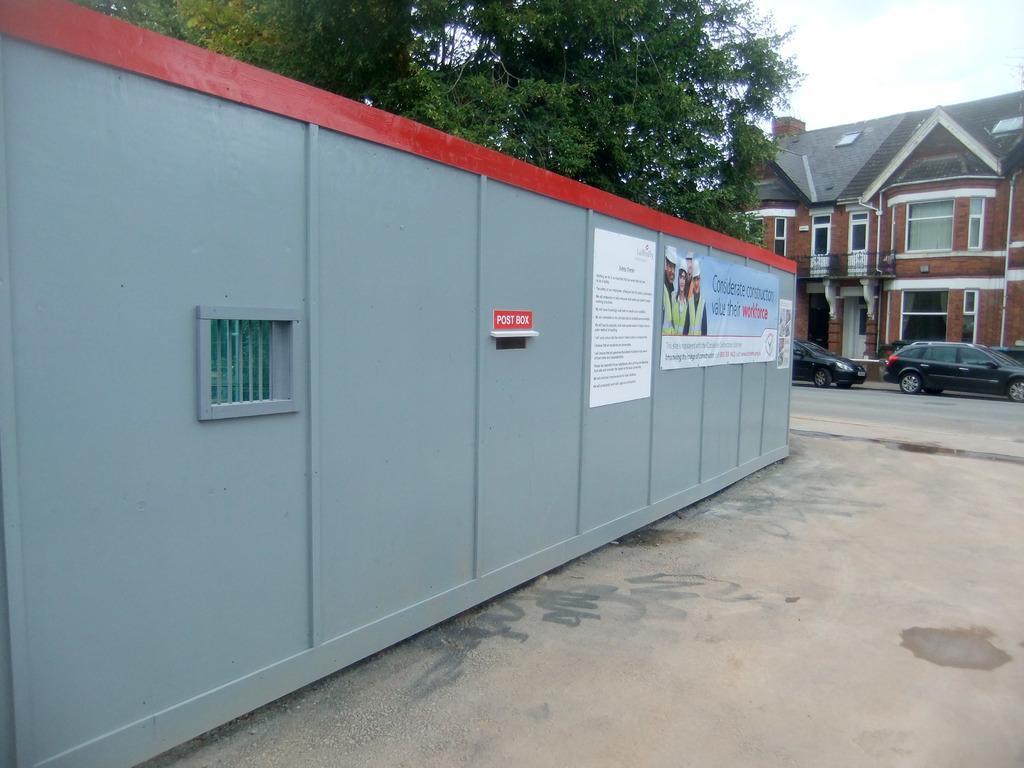Describe this image in one or two sentences. In the middle of the image we can see a wall, on the wall there are some banners and sign board. Behind the wall there are some trees. On the right side of the image there are some vehicles on the road. Behind the vehicles there is a building. In the top right corner of the image there is the sky. 